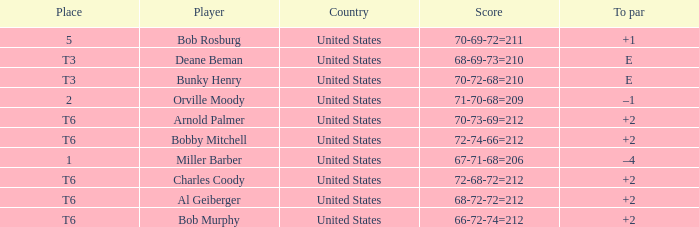What is the tally of player bob rosburg? 70-69-72=211. 